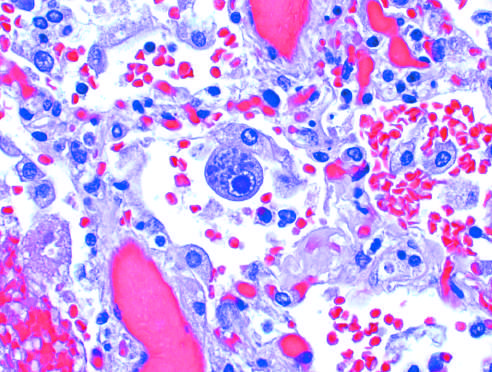what are a distinct nuclear inclusion and multiple cytoplasmic inclusions seen in?
Answer the question using a single word or phrase. An enlarged cell 